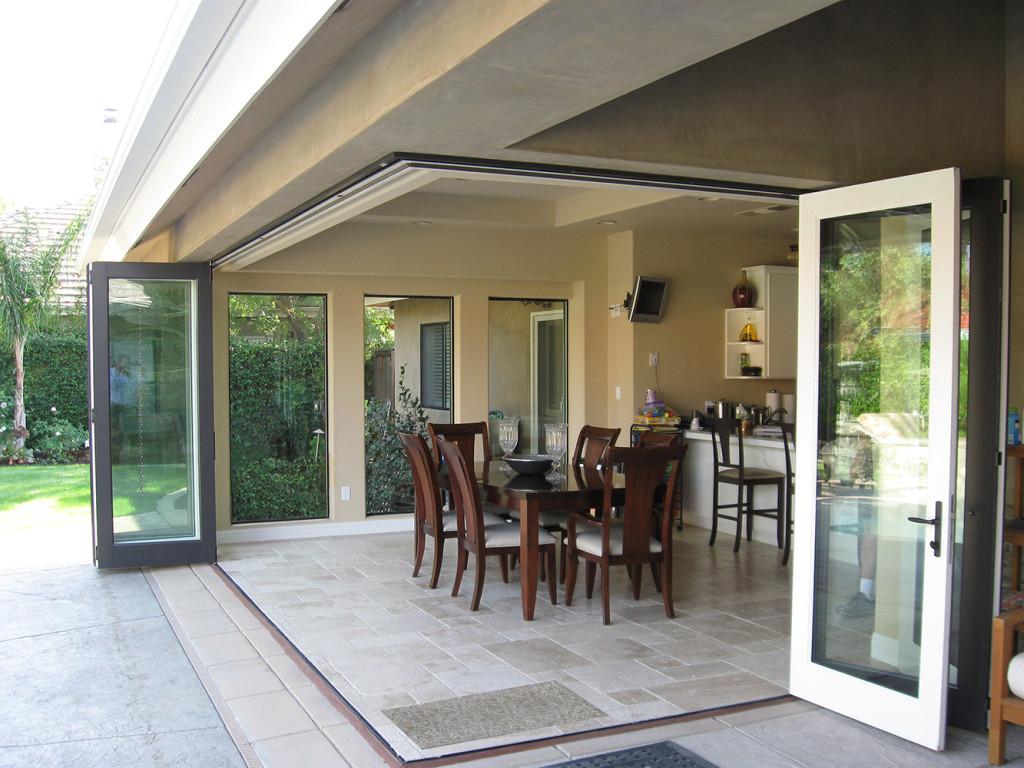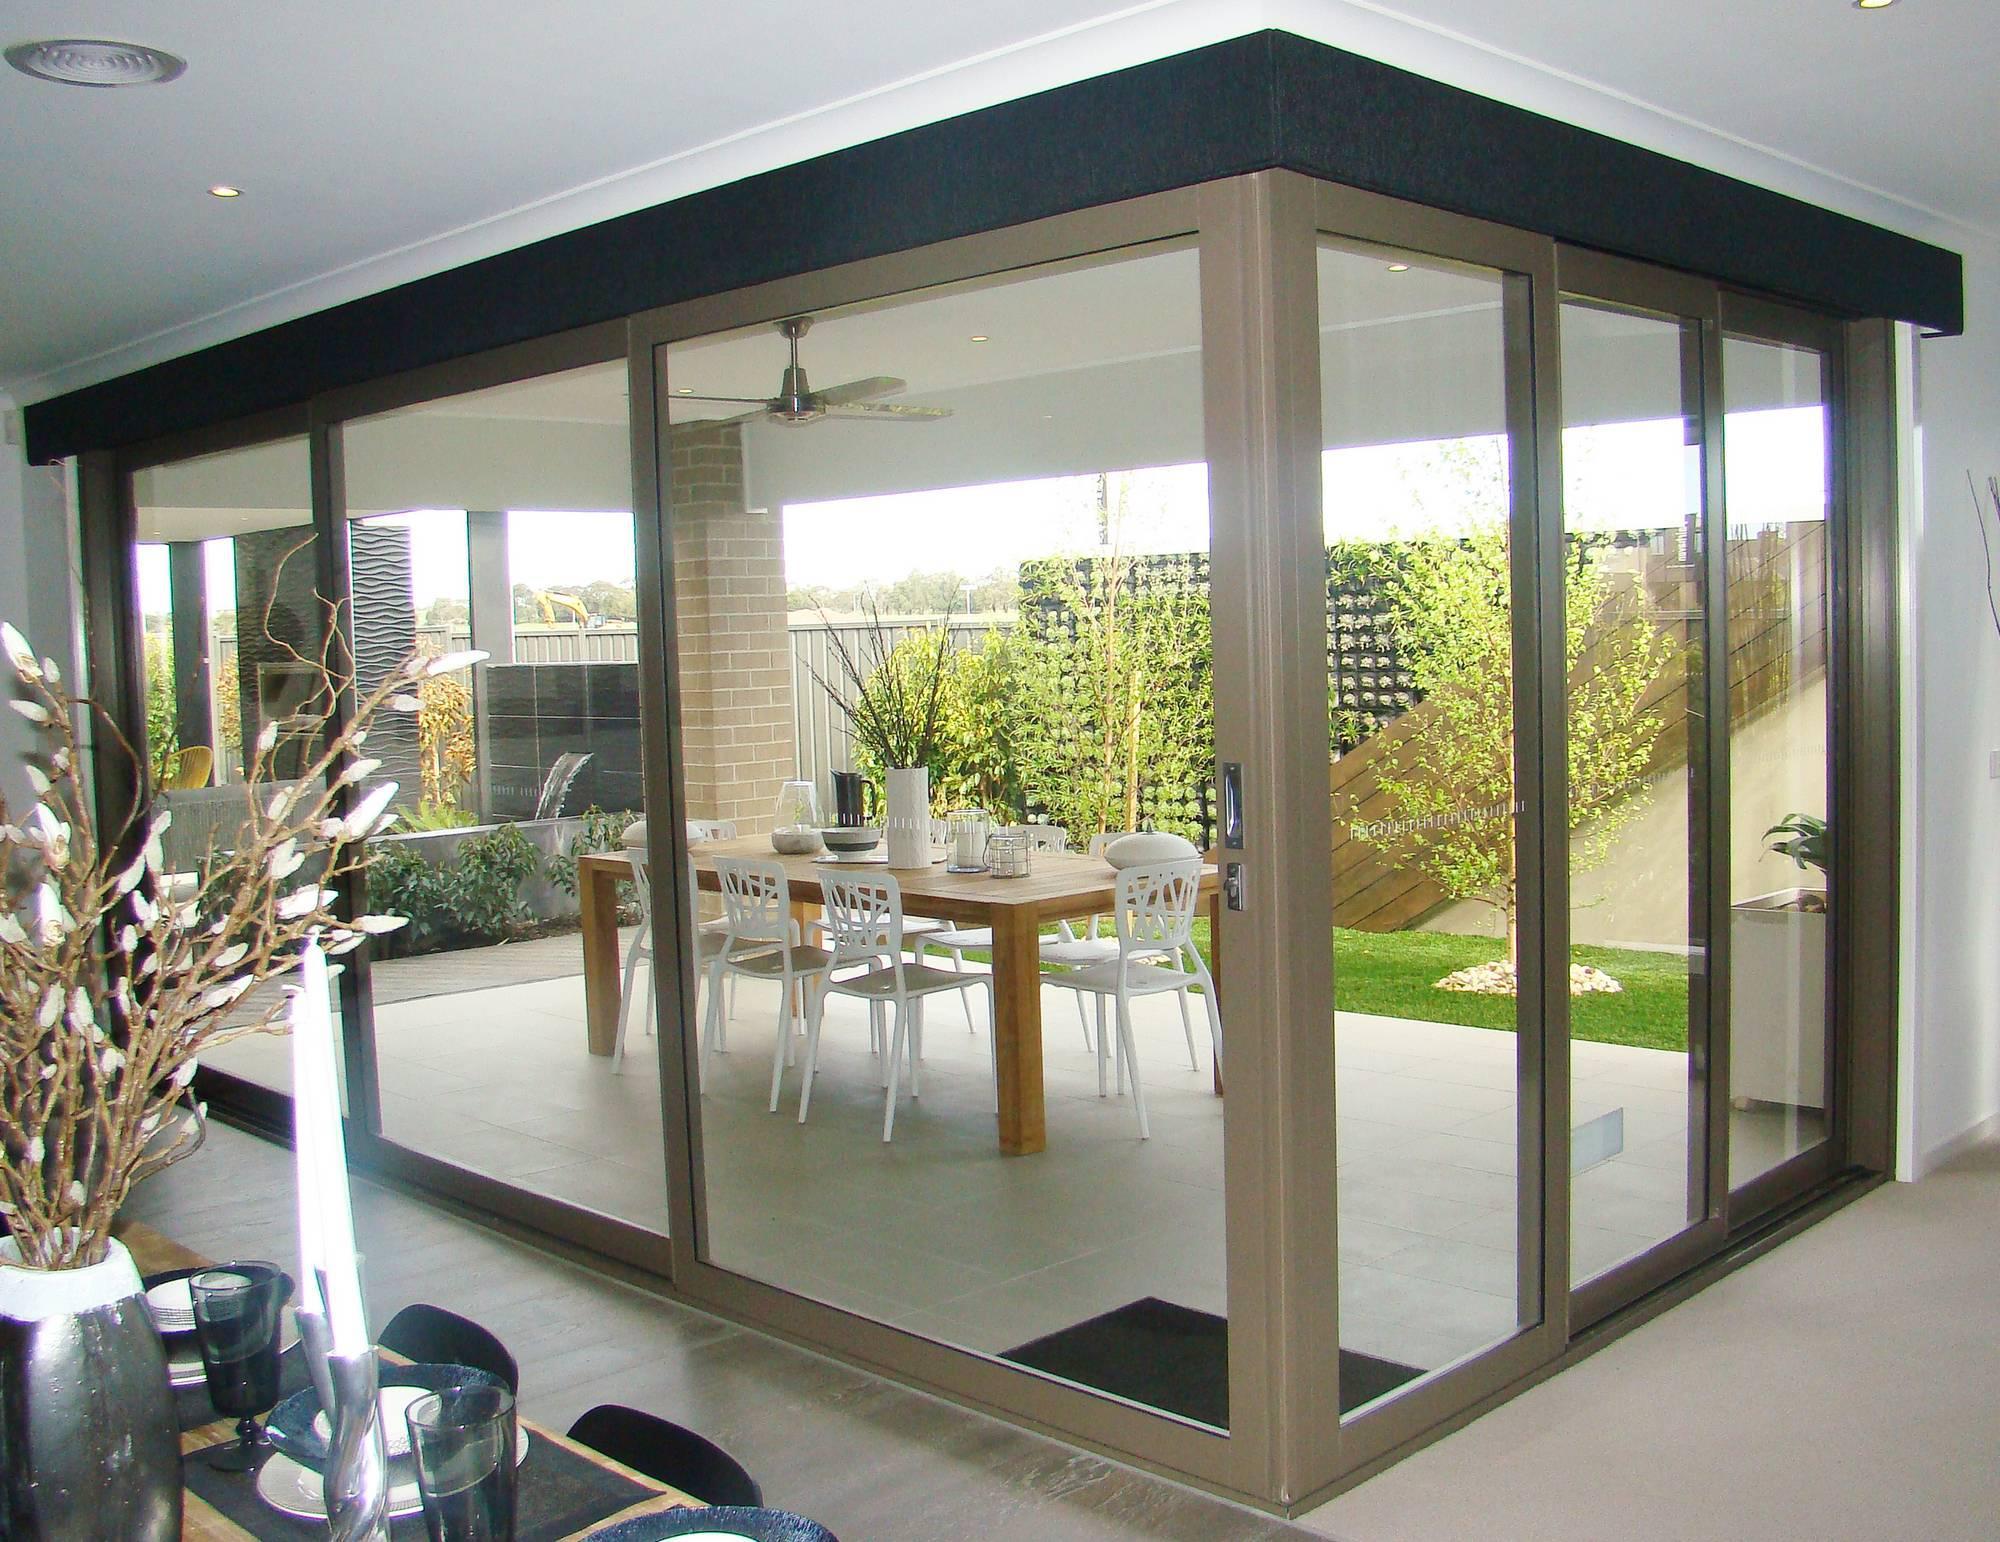The first image is the image on the left, the second image is the image on the right. Assess this claim about the two images: "The doors are open in the right image.". Correct or not? Answer yes or no. No. 